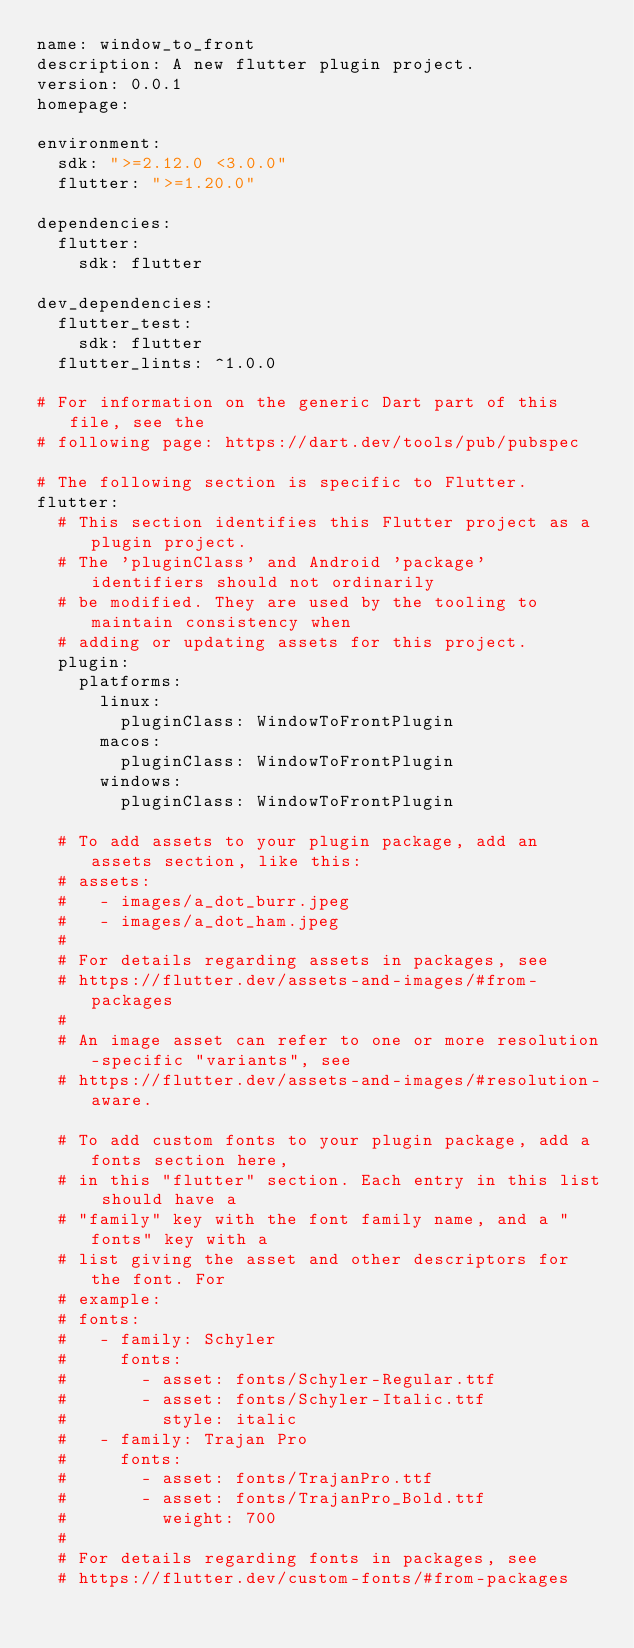<code> <loc_0><loc_0><loc_500><loc_500><_YAML_>name: window_to_front
description: A new flutter plugin project.
version: 0.0.1
homepage:

environment:
  sdk: ">=2.12.0 <3.0.0"
  flutter: ">=1.20.0"

dependencies:
  flutter:
    sdk: flutter

dev_dependencies:
  flutter_test:
    sdk: flutter
  flutter_lints: ^1.0.0

# For information on the generic Dart part of this file, see the
# following page: https://dart.dev/tools/pub/pubspec

# The following section is specific to Flutter.
flutter:
  # This section identifies this Flutter project as a plugin project.
  # The 'pluginClass' and Android 'package' identifiers should not ordinarily
  # be modified. They are used by the tooling to maintain consistency when
  # adding or updating assets for this project.
  plugin:
    platforms:
      linux:
        pluginClass: WindowToFrontPlugin
      macos:
        pluginClass: WindowToFrontPlugin
      windows:
        pluginClass: WindowToFrontPlugin

  # To add assets to your plugin package, add an assets section, like this:
  # assets:
  #   - images/a_dot_burr.jpeg
  #   - images/a_dot_ham.jpeg
  #
  # For details regarding assets in packages, see
  # https://flutter.dev/assets-and-images/#from-packages
  #
  # An image asset can refer to one or more resolution-specific "variants", see
  # https://flutter.dev/assets-and-images/#resolution-aware.

  # To add custom fonts to your plugin package, add a fonts section here,
  # in this "flutter" section. Each entry in this list should have a
  # "family" key with the font family name, and a "fonts" key with a
  # list giving the asset and other descriptors for the font. For
  # example:
  # fonts:
  #   - family: Schyler
  #     fonts:
  #       - asset: fonts/Schyler-Regular.ttf
  #       - asset: fonts/Schyler-Italic.ttf
  #         style: italic
  #   - family: Trajan Pro
  #     fonts:
  #       - asset: fonts/TrajanPro.ttf
  #       - asset: fonts/TrajanPro_Bold.ttf
  #         weight: 700
  #
  # For details regarding fonts in packages, see
  # https://flutter.dev/custom-fonts/#from-packages
</code> 